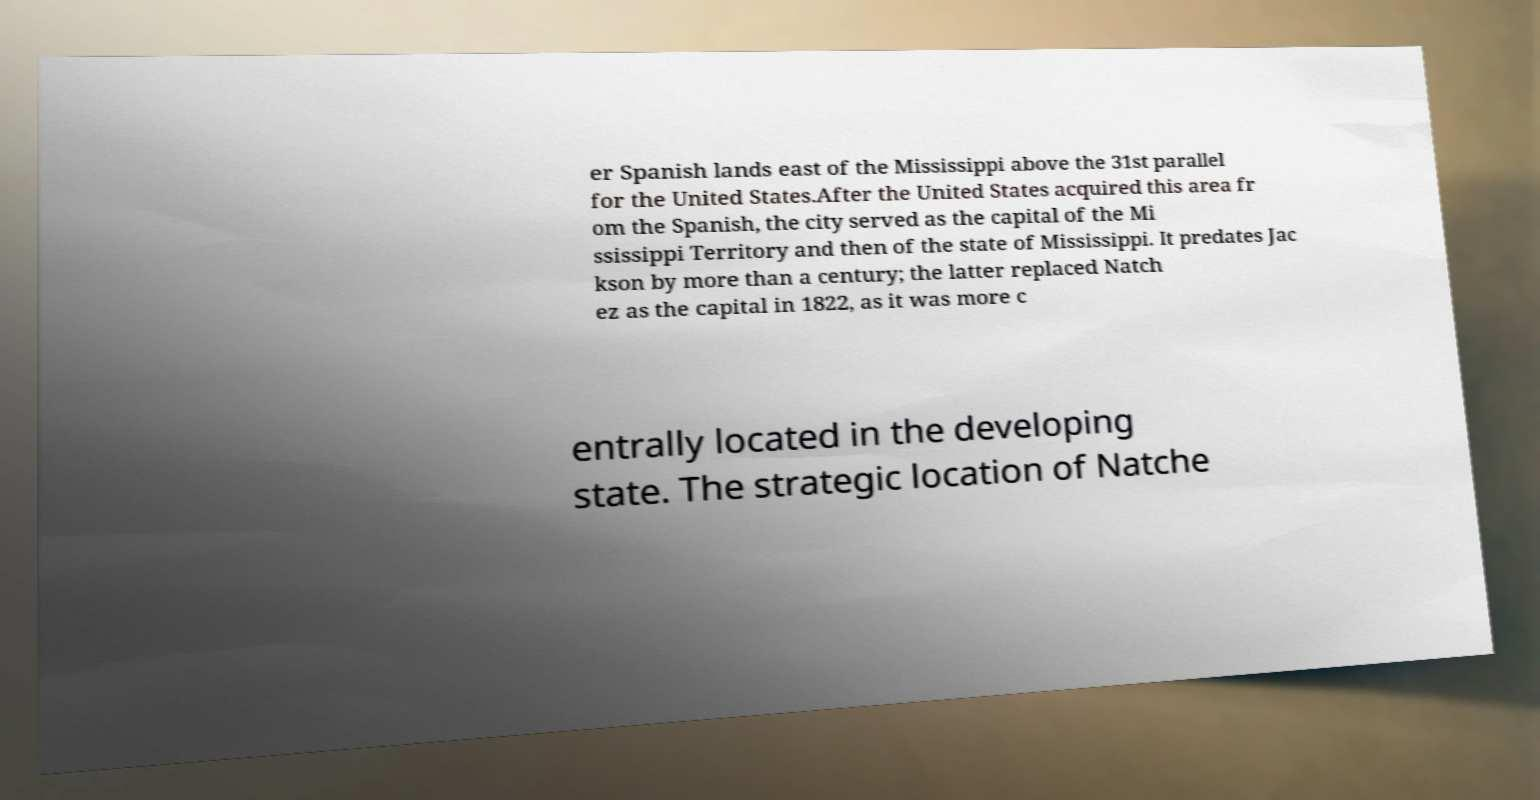Please read and relay the text visible in this image. What does it say? er Spanish lands east of the Mississippi above the 31st parallel for the United States.After the United States acquired this area fr om the Spanish, the city served as the capital of the Mi ssissippi Territory and then of the state of Mississippi. It predates Jac kson by more than a century; the latter replaced Natch ez as the capital in 1822, as it was more c entrally located in the developing state. The strategic location of Natche 